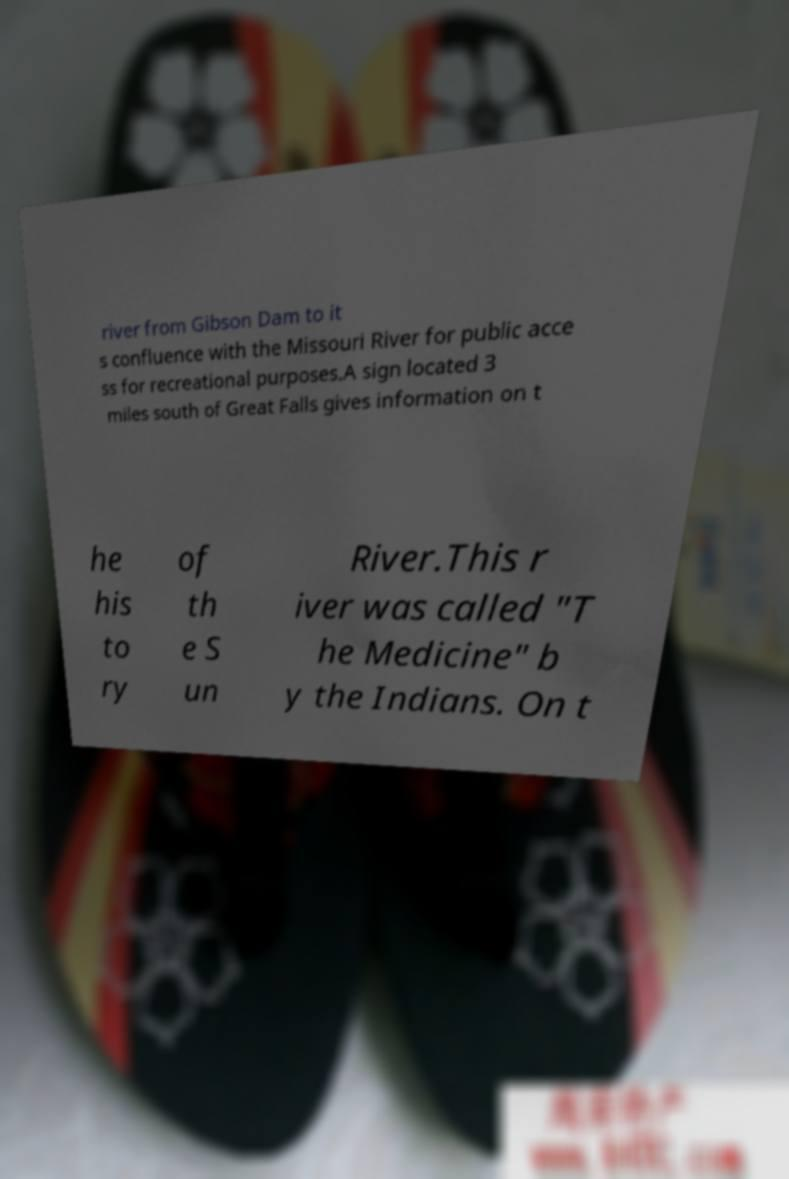There's text embedded in this image that I need extracted. Can you transcribe it verbatim? river from Gibson Dam to it s confluence with the Missouri River for public acce ss for recreational purposes.A sign located 3 miles south of Great Falls gives information on t he his to ry of th e S un River.This r iver was called "T he Medicine" b y the Indians. On t 